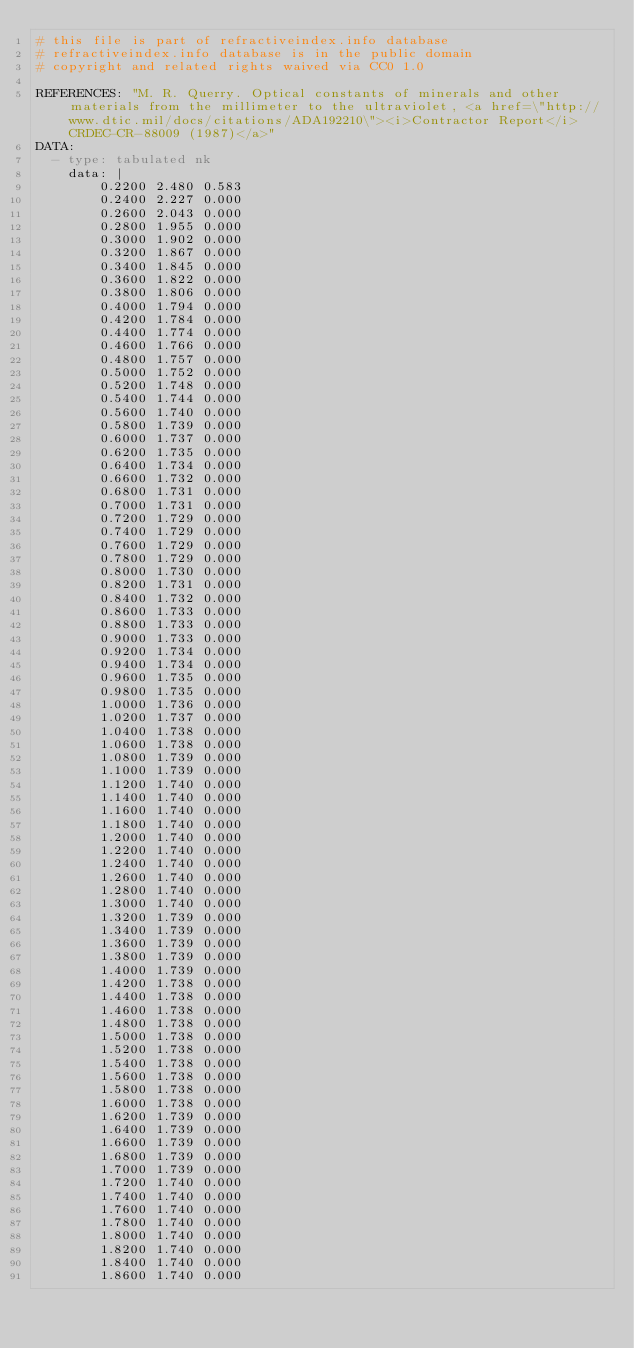<code> <loc_0><loc_0><loc_500><loc_500><_YAML_># this file is part of refractiveindex.info database
# refractiveindex.info database is in the public domain
# copyright and related rights waived via CC0 1.0

REFERENCES: "M. R. Querry. Optical constants of minerals and other materials from the millimeter to the ultraviolet, <a href=\"http://www.dtic.mil/docs/citations/ADA192210\"><i>Contractor Report</i> CRDEC-CR-88009 (1987)</a>"
DATA:
  - type: tabulated nk
    data: |
        0.2200 2.480 0.583
        0.2400 2.227 0.000
        0.2600 2.043 0.000
        0.2800 1.955 0.000
        0.3000 1.902 0.000
        0.3200 1.867 0.000
        0.3400 1.845 0.000
        0.3600 1.822 0.000
        0.3800 1.806 0.000
        0.4000 1.794 0.000
        0.4200 1.784 0.000
        0.4400 1.774 0.000
        0.4600 1.766 0.000
        0.4800 1.757 0.000
        0.5000 1.752 0.000
        0.5200 1.748 0.000
        0.5400 1.744 0.000
        0.5600 1.740 0.000
        0.5800 1.739 0.000
        0.6000 1.737 0.000
        0.6200 1.735 0.000
        0.6400 1.734 0.000
        0.6600 1.732 0.000
        0.6800 1.731 0.000
        0.7000 1.731 0.000
        0.7200 1.729 0.000
        0.7400 1.729 0.000
        0.7600 1.729 0.000
        0.7800 1.729 0.000
        0.8000 1.730 0.000
        0.8200 1.731 0.000
        0.8400 1.732 0.000
        0.8600 1.733 0.000
        0.8800 1.733 0.000
        0.9000 1.733 0.000
        0.9200 1.734 0.000
        0.9400 1.734 0.000
        0.9600 1.735 0.000
        0.9800 1.735 0.000
        1.0000 1.736 0.000
        1.0200 1.737 0.000
        1.0400 1.738 0.000
        1.0600 1.738 0.000
        1.0800 1.739 0.000
        1.1000 1.739 0.000
        1.1200 1.740 0.000
        1.1400 1.740 0.000
        1.1600 1.740 0.000
        1.1800 1.740 0.000
        1.2000 1.740 0.000
        1.2200 1.740 0.000
        1.2400 1.740 0.000
        1.2600 1.740 0.000
        1.2800 1.740 0.000
        1.3000 1.740 0.000
        1.3200 1.739 0.000
        1.3400 1.739 0.000
        1.3600 1.739 0.000
        1.3800 1.739 0.000
        1.4000 1.739 0.000
        1.4200 1.738 0.000
        1.4400 1.738 0.000
        1.4600 1.738 0.000
        1.4800 1.738 0.000
        1.5000 1.738 0.000
        1.5200 1.738 0.000
        1.5400 1.738 0.000
        1.5600 1.738 0.000
        1.5800 1.738 0.000
        1.6000 1.738 0.000
        1.6200 1.739 0.000
        1.6400 1.739 0.000
        1.6600 1.739 0.000
        1.6800 1.739 0.000
        1.7000 1.739 0.000
        1.7200 1.740 0.000
        1.7400 1.740 0.000
        1.7600 1.740 0.000
        1.7800 1.740 0.000
        1.8000 1.740 0.000
        1.8200 1.740 0.000
        1.8400 1.740 0.000
        1.8600 1.740 0.000</code> 